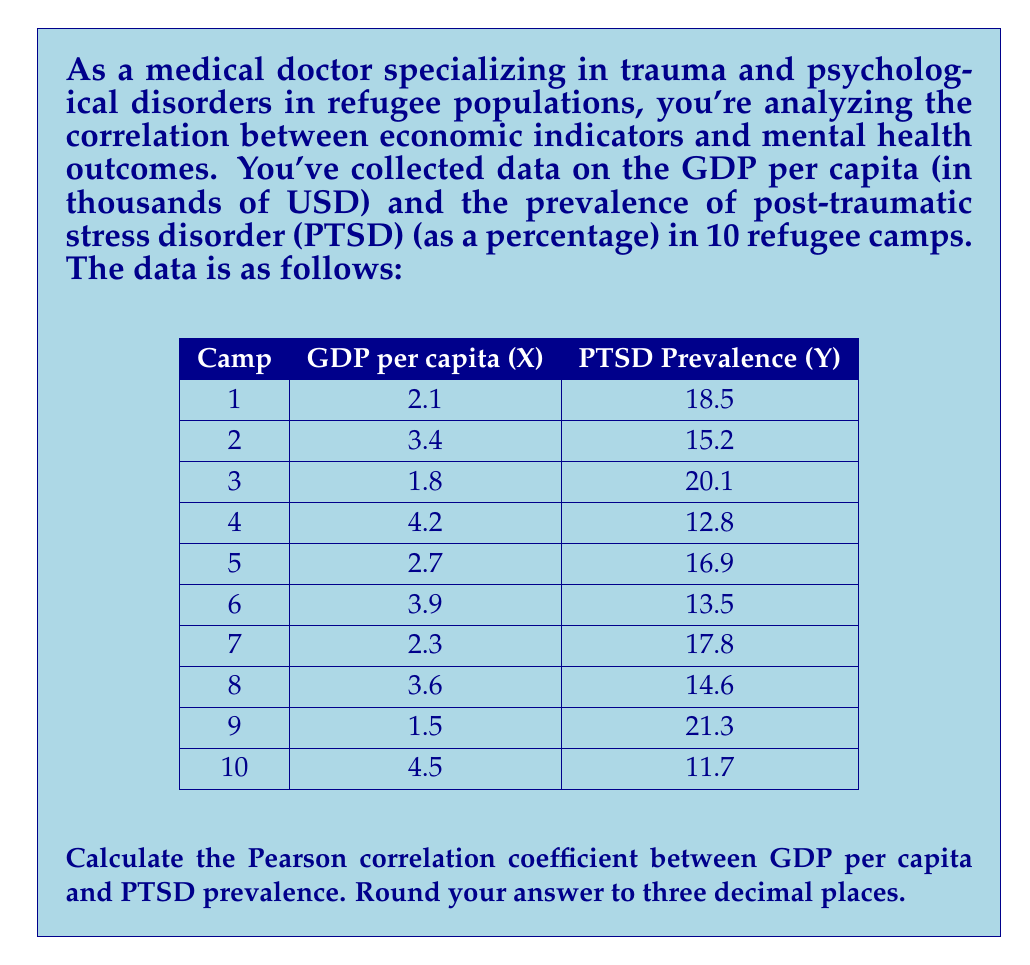Solve this math problem. To calculate the Pearson correlation coefficient, we'll use the formula:

$$ r = \frac{\sum_{i=1}^{n} (x_i - \bar{x})(y_i - \bar{y})}{\sqrt{\sum_{i=1}^{n} (x_i - \bar{x})^2} \sqrt{\sum_{i=1}^{n} (y_i - \bar{y})^2}} $$

Where:
$x_i$ and $y_i$ are the individual sample points
$\bar{x}$ and $\bar{y}$ are the sample means

Step 1: Calculate the means
$\bar{x} = \frac{2.1 + 3.4 + 1.8 + 4.2 + 2.7 + 3.9 + 2.3 + 3.6 + 1.5 + 4.5}{10} = 3.0$
$\bar{y} = \frac{18.5 + 15.2 + 20.1 + 12.8 + 16.9 + 13.5 + 17.8 + 14.6 + 21.3 + 11.7}{10} = 16.24$

Step 2: Calculate $(x_i - \bar{x})$, $(y_i - \bar{y})$, $(x_i - \bar{x})^2$, $(y_i - \bar{y})^2$, and $(x_i - \bar{x})(y_i - \bar{y})$ for each data point.

Step 3: Sum up the results:
$\sum (x_i - \bar{x})(y_i - \bar{y}) = -22.636$
$\sum (x_i - \bar{x})^2 = 9.1$
$\sum (y_i - \bar{y})^2 = 106.204$

Step 4: Apply the formula:

$$ r = \frac{-22.636}{\sqrt{9.1} \sqrt{106.204}} = \frac{-22.636}{31.058} = -0.7288 $$

Step 5: Round to three decimal places: -0.729
Answer: -0.729 